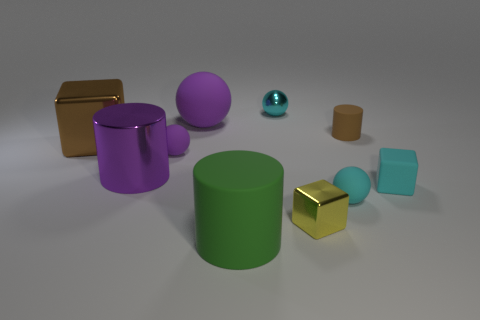There is another ball that is the same color as the large rubber ball; what is its size?
Keep it short and to the point. Small. Does the small cylinder have the same color as the large block?
Keep it short and to the point. Yes. There is a cube that is the same color as the small shiny sphere; what material is it?
Provide a short and direct response. Rubber. How many blocks have the same material as the green thing?
Make the answer very short. 1. There is another cube that is the same material as the yellow cube; what is its color?
Offer a terse response. Brown. Is the size of the rubber cylinder in front of the cyan matte cube the same as the tiny cylinder?
Your answer should be very brief. No. The other large thing that is the same shape as the big purple metallic thing is what color?
Your response must be concise. Green. What is the shape of the brown thing to the left of the tiny yellow block in front of the small matte object that is left of the tiny yellow metal object?
Your answer should be very brief. Cube. Is the yellow object the same shape as the large brown shiny object?
Your response must be concise. Yes. There is a cyan thing that is left of the small metallic thing in front of the cyan metal sphere; what shape is it?
Ensure brevity in your answer.  Sphere. 